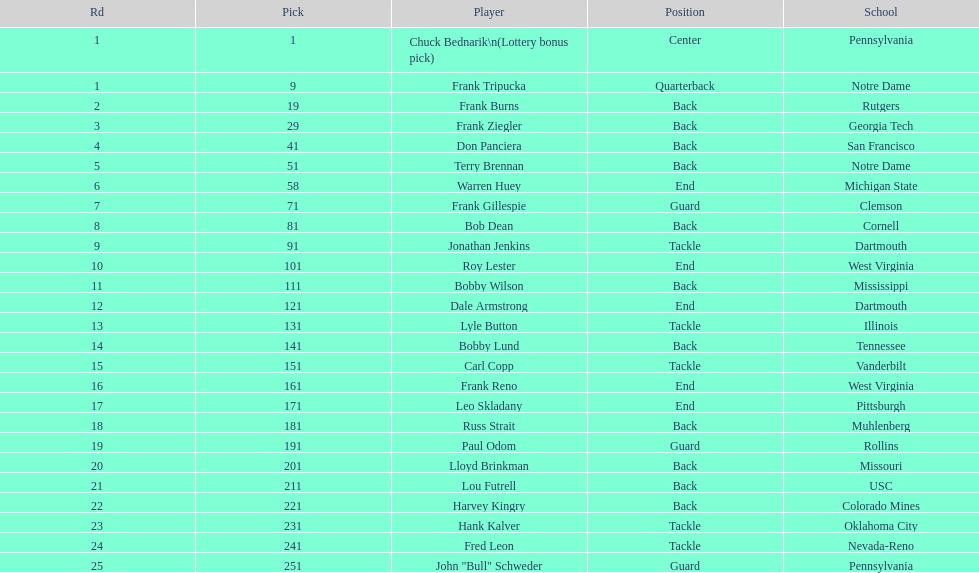Who was the player that the team drafted after bob dean? Jonathan Jenkins. 